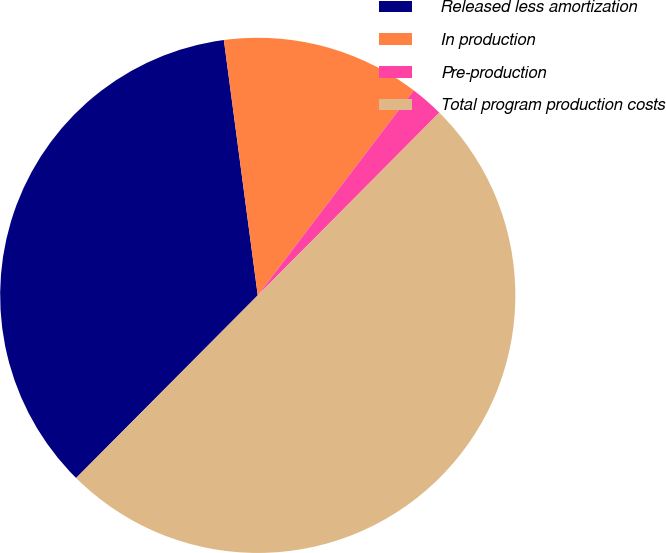<chart> <loc_0><loc_0><loc_500><loc_500><pie_chart><fcel>Released less amortization<fcel>In production<fcel>Pre-production<fcel>Total program production costs<nl><fcel>35.44%<fcel>12.45%<fcel>2.1%<fcel>50.0%<nl></chart> 